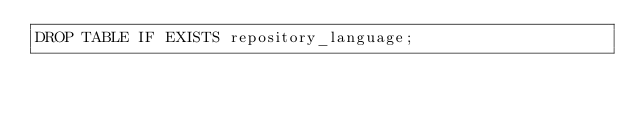<code> <loc_0><loc_0><loc_500><loc_500><_SQL_>DROP TABLE IF EXISTS repository_language;</code> 